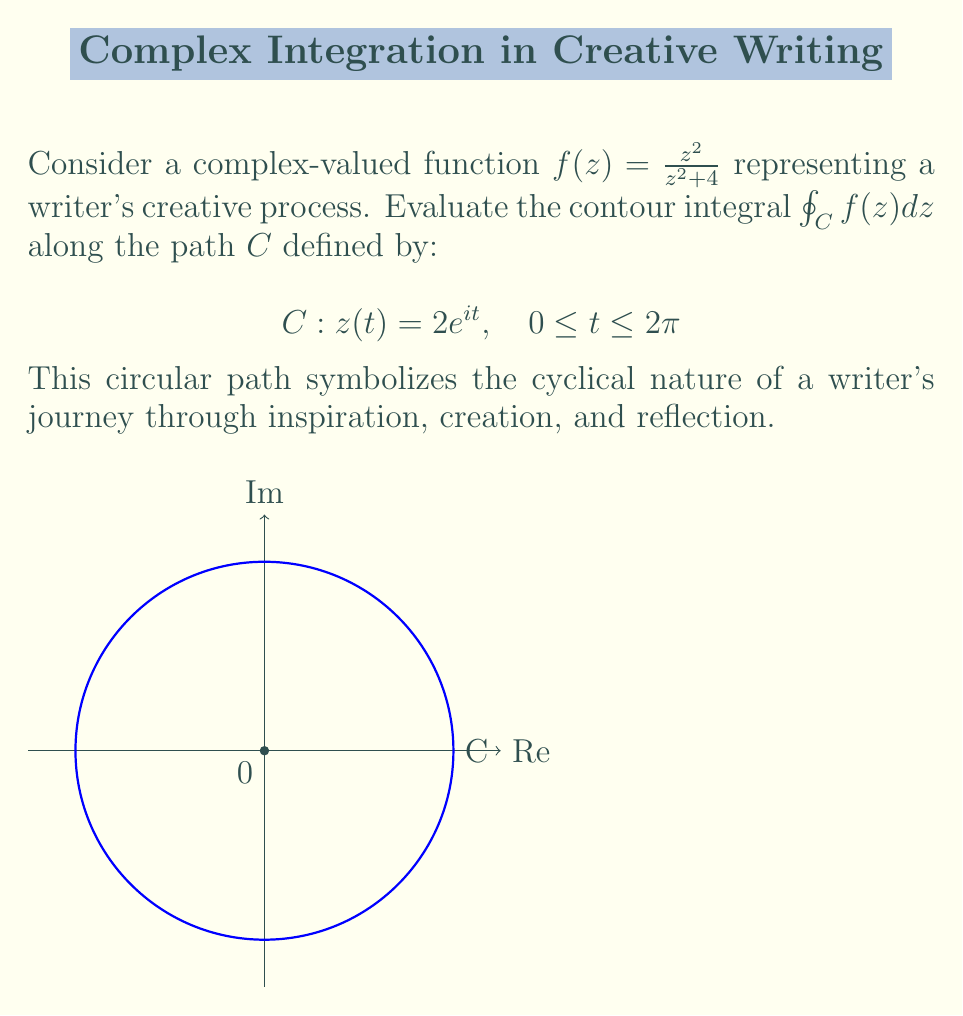Can you solve this math problem? Let's approach this step-by-step:

1) First, we need to check if there are any singularities inside the contour. The function $f(z) = \frac{z^2}{z^2 + 4}$ has poles at $z = \pm 2i$. Our contour is a circle with radius 2 centered at the origin, so it doesn't enclose these poles.

2) Since there are no singularities inside the contour, we can use Cauchy's integral theorem, which states that $\oint_C f(z) dz = 0$ for any analytic function $f(z)$ inside and on $C$.

3) However, let's verify this using the parametrization given:

   $z = 2e^{it}, \quad 0 \leq t \leq 2\pi$
   $dz = 2ie^{it} dt$

4) Substituting into the integral:

   $$\oint_C f(z) dz = \int_0^{2\pi} \frac{(2e^{it})^2}{(2e^{it})^2 + 4} \cdot 2ie^{it} dt$$

5) Simplify:

   $$= \int_0^{2\pi} \frac{4e^{2it}}{4e^{2it} + 4} \cdot 2ie^{it} dt = \int_0^{2\pi} \frac{4ie^{3it}}{e^{2it} + 1} dt$$

6) Let $u = e^{2it}$, then $du = 2ie^{2it} dt$, and when $t$ goes from 0 to $2\pi$, $u$ goes around the unit circle once.

   $$= \oint_{|u|=1} \frac{2u^{1/2}}{u + 1} du$$

7) This integral is zero because the integrand is analytic inside and on the unit circle (the pole at $u=-1$ is outside).

Therefore, the value of the integral is 0, confirming Cauchy's integral theorem.
Answer: $0$ 